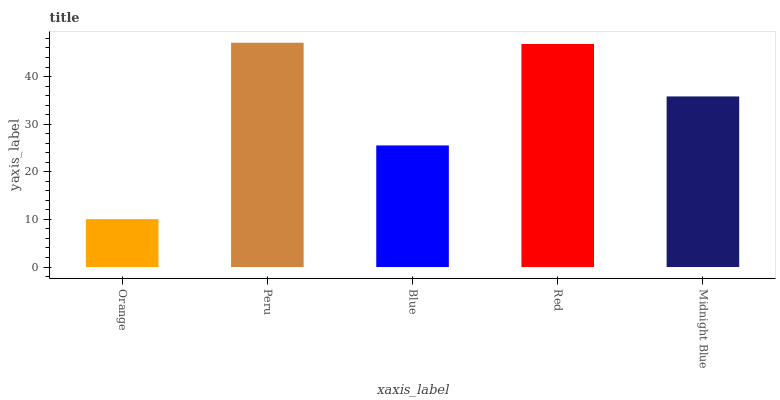Is Orange the minimum?
Answer yes or no. Yes. Is Peru the maximum?
Answer yes or no. Yes. Is Blue the minimum?
Answer yes or no. No. Is Blue the maximum?
Answer yes or no. No. Is Peru greater than Blue?
Answer yes or no. Yes. Is Blue less than Peru?
Answer yes or no. Yes. Is Blue greater than Peru?
Answer yes or no. No. Is Peru less than Blue?
Answer yes or no. No. Is Midnight Blue the high median?
Answer yes or no. Yes. Is Midnight Blue the low median?
Answer yes or no. Yes. Is Blue the high median?
Answer yes or no. No. Is Blue the low median?
Answer yes or no. No. 